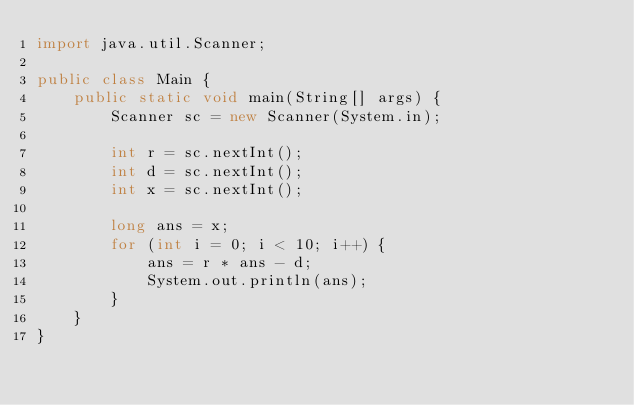<code> <loc_0><loc_0><loc_500><loc_500><_Java_>import java.util.Scanner;

public class Main {
    public static void main(String[] args) {
        Scanner sc = new Scanner(System.in);
        
        int r = sc.nextInt();
        int d = sc.nextInt();
        int x = sc.nextInt();
        
        long ans = x;
        for (int i = 0; i < 10; i++) {
            ans = r * ans - d;
            System.out.println(ans);
        }
    }
}</code> 